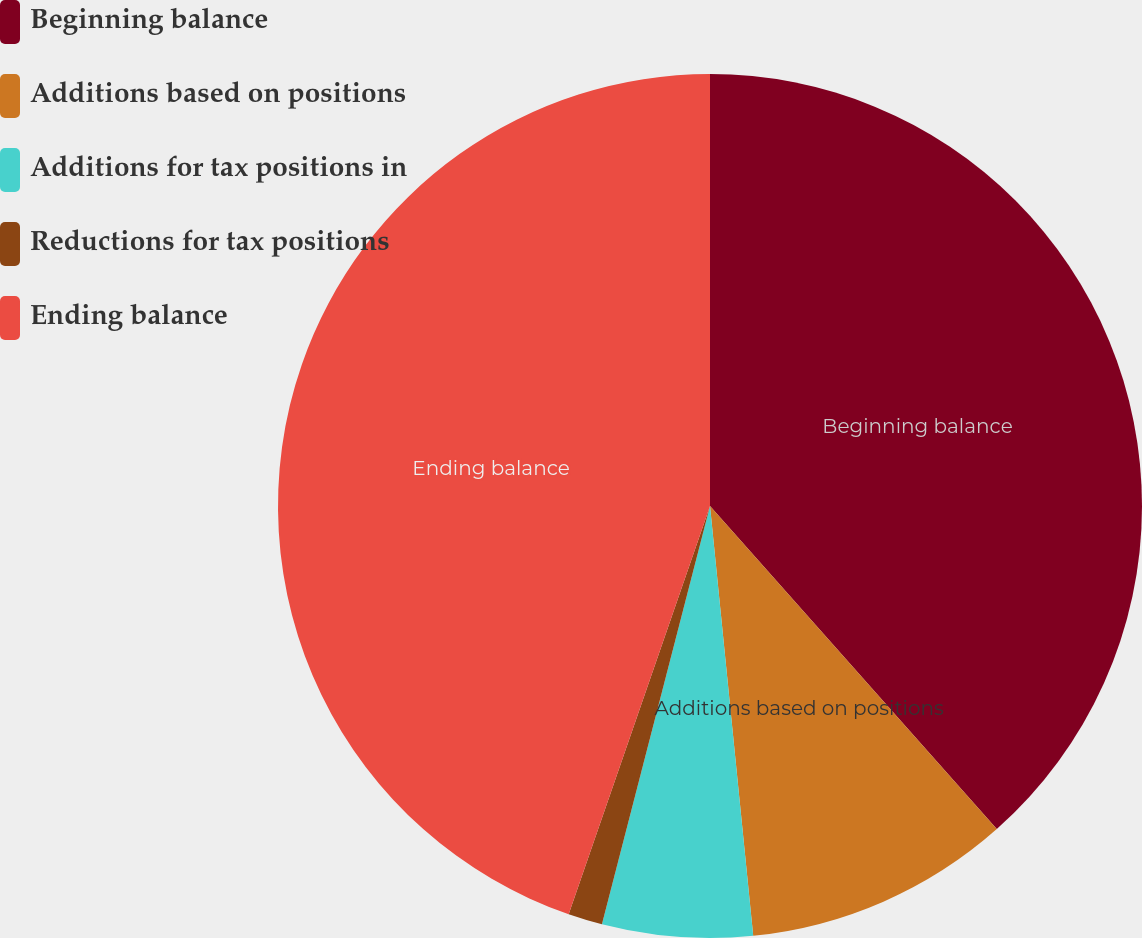Convert chart. <chart><loc_0><loc_0><loc_500><loc_500><pie_chart><fcel>Beginning balance<fcel>Additions based on positions<fcel>Additions for tax positions in<fcel>Reductions for tax positions<fcel>Ending balance<nl><fcel>38.45%<fcel>9.96%<fcel>5.62%<fcel>1.28%<fcel>44.7%<nl></chart> 